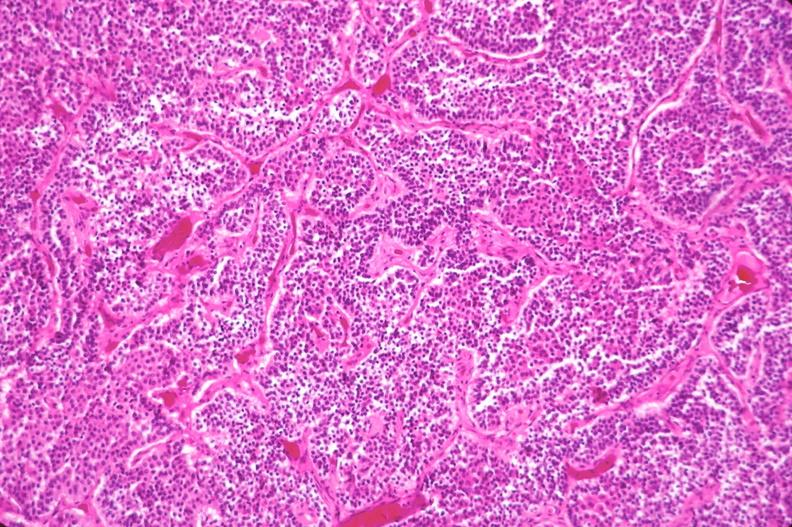what does this image show?
Answer the question using a single word or phrase. Pituitary 